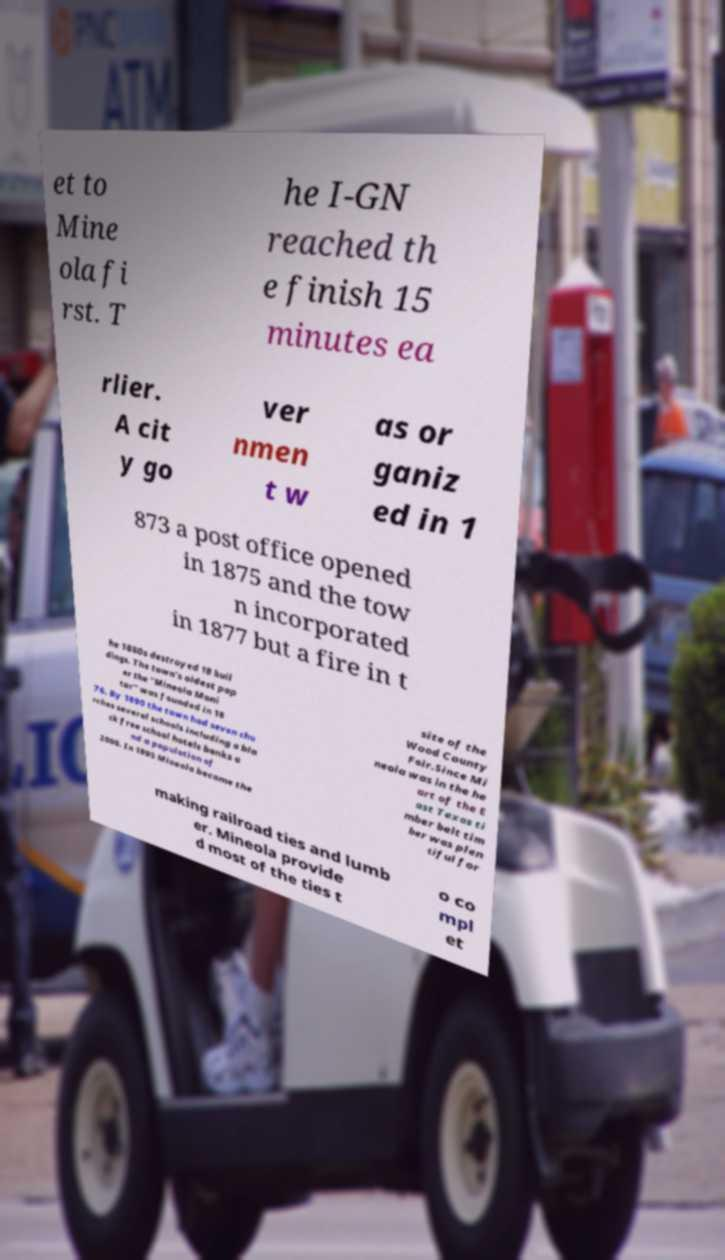Could you assist in decoding the text presented in this image and type it out clearly? et to Mine ola fi rst. T he I-GN reached th e finish 15 minutes ea rlier. A cit y go ver nmen t w as or ganiz ed in 1 873 a post office opened in 1875 and the tow n incorporated in 1877 but a fire in t he 1880s destroyed 18 buil dings. The town's oldest pap er the "Mineola Moni tor" was founded in 18 76. By 1890 the town had seven chu rches several schools including a bla ck free school hotels banks a nd a population of 2000. In 1895 Mineola became the site of the Wood County Fair.Since Mi neola was in the he art of the E ast Texas ti mber belt tim ber was plen tiful for making railroad ties and lumb er. Mineola provide d most of the ties t o co mpl et 